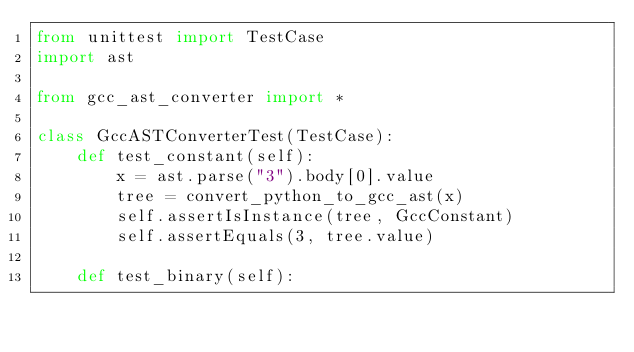<code> <loc_0><loc_0><loc_500><loc_500><_Python_>from unittest import TestCase
import ast

from gcc_ast_converter import *

class GccASTConverterTest(TestCase):
    def test_constant(self):
        x = ast.parse("3").body[0].value
        tree = convert_python_to_gcc_ast(x)
        self.assertIsInstance(tree, GccConstant)
        self.assertEquals(3, tree.value)

    def test_binary(self):</code> 